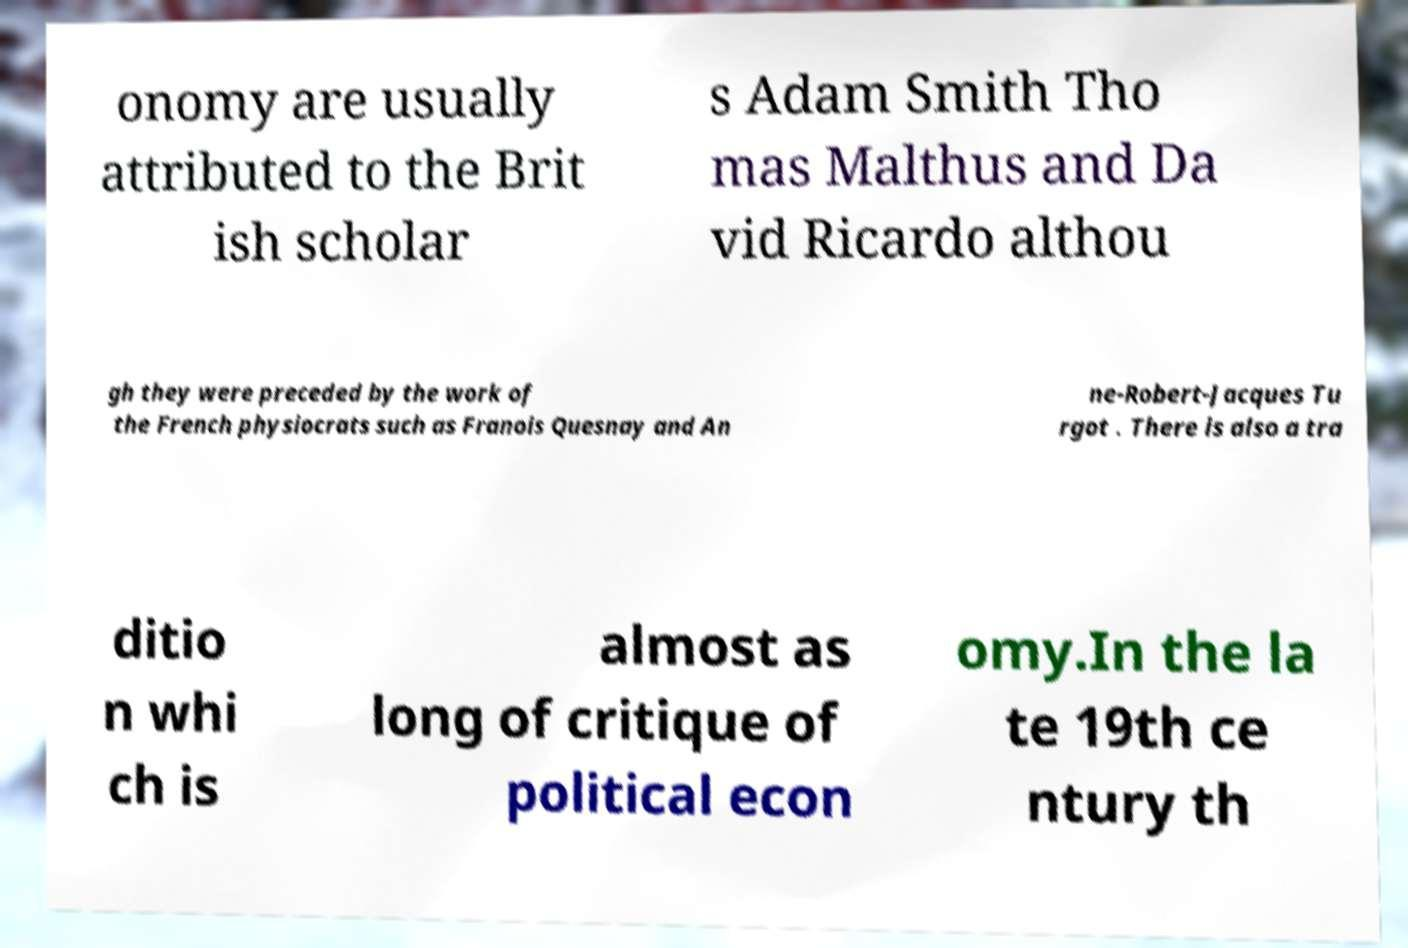Can you accurately transcribe the text from the provided image for me? onomy are usually attributed to the Brit ish scholar s Adam Smith Tho mas Malthus and Da vid Ricardo althou gh they were preceded by the work of the French physiocrats such as Franois Quesnay and An ne-Robert-Jacques Tu rgot . There is also a tra ditio n whi ch is almost as long of critique of political econ omy.In the la te 19th ce ntury th 